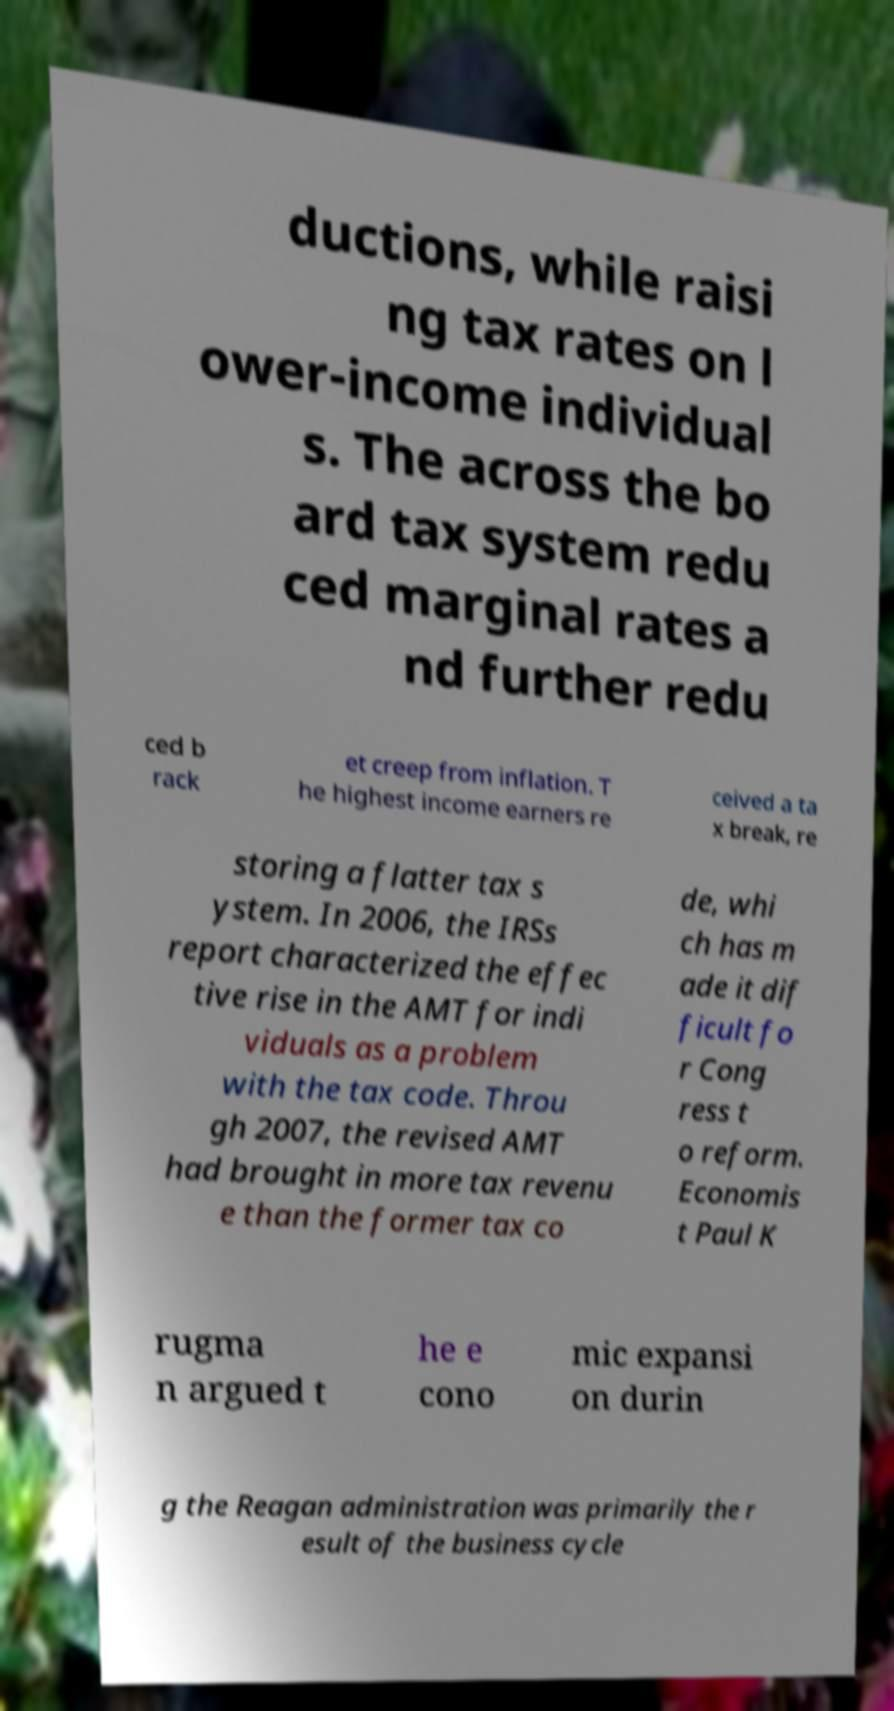Can you read and provide the text displayed in the image?This photo seems to have some interesting text. Can you extract and type it out for me? ductions, while raisi ng tax rates on l ower-income individual s. The across the bo ard tax system redu ced marginal rates a nd further redu ced b rack et creep from inflation. T he highest income earners re ceived a ta x break, re storing a flatter tax s ystem. In 2006, the IRSs report characterized the effec tive rise in the AMT for indi viduals as a problem with the tax code. Throu gh 2007, the revised AMT had brought in more tax revenu e than the former tax co de, whi ch has m ade it dif ficult fo r Cong ress t o reform. Economis t Paul K rugma n argued t he e cono mic expansi on durin g the Reagan administration was primarily the r esult of the business cycle 